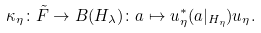<formula> <loc_0><loc_0><loc_500><loc_500>\kappa _ { \eta } \colon \tilde { F } \rightarrow B ( H _ { \lambda } ) \colon a \mapsto u _ { \eta } ^ { \ast } ( a | _ { H _ { \eta } } ) u _ { \eta } .</formula> 